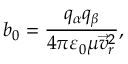<formula> <loc_0><loc_0><loc_500><loc_500>{ { b } _ { 0 } } = \frac { { { q } _ { \alpha } } { { q } _ { \beta } } } { 4 \pi { { \varepsilon } _ { 0 } } \mu { { \vec { v } _ { r } } ^ { 2 } } } ,</formula> 